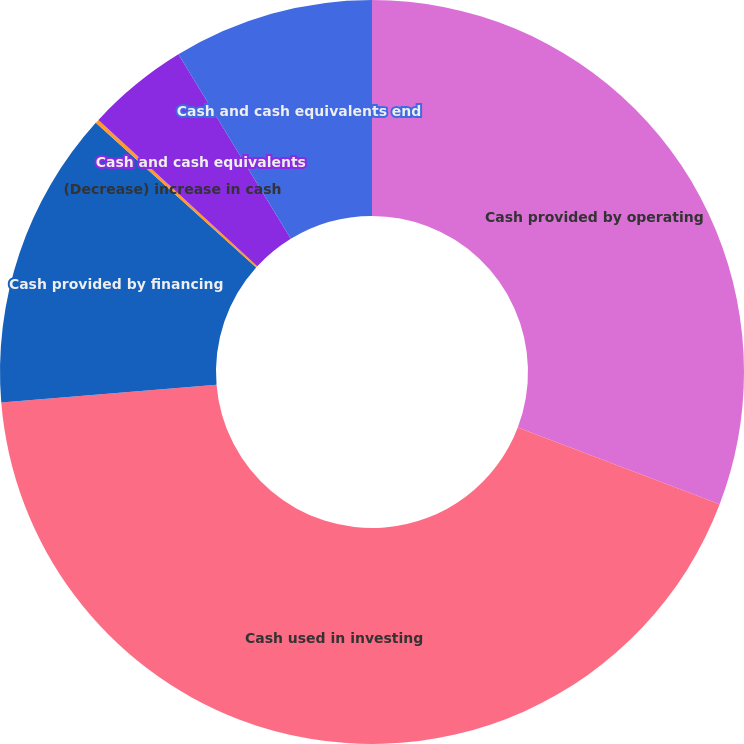Convert chart to OTSL. <chart><loc_0><loc_0><loc_500><loc_500><pie_chart><fcel>Cash provided by operating<fcel>Cash used in investing<fcel>Cash provided by financing<fcel>(Decrease) increase in cash<fcel>Cash and cash equivalents<fcel>Cash and cash equivalents end<nl><fcel>30.79%<fcel>42.9%<fcel>12.99%<fcel>0.17%<fcel>4.44%<fcel>8.71%<nl></chart> 